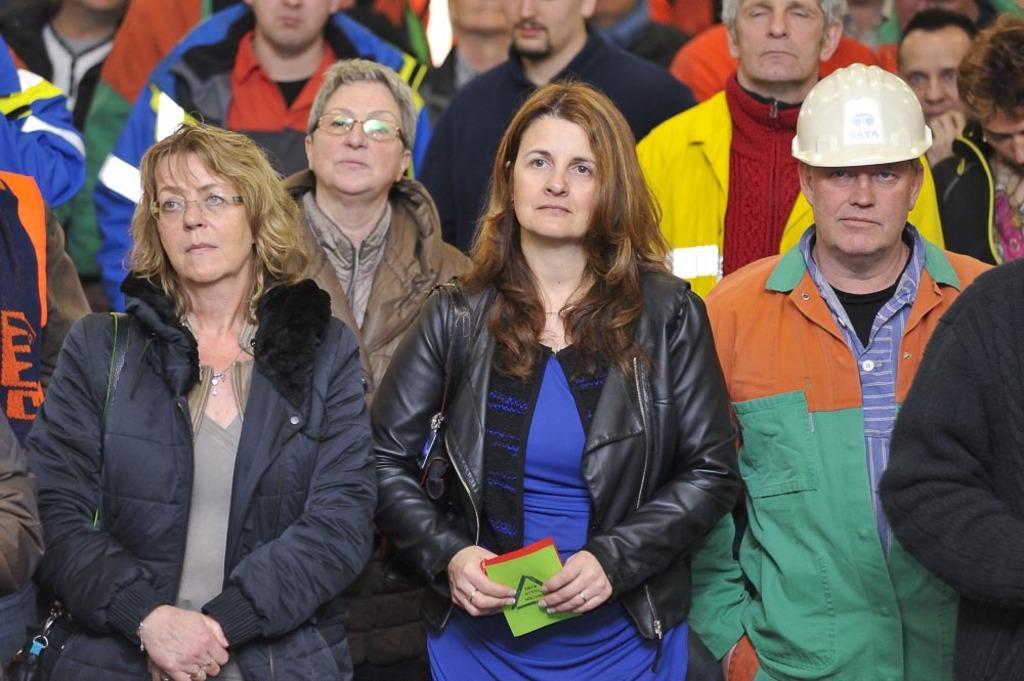Describe this image in one or two sentences. In this image I can see in the middle a woman is standing, she wore a black color coat and also holding a book in her hand. On the right side a man is standing, he wore helmet, coat. Beside him a group of people are also standing. 